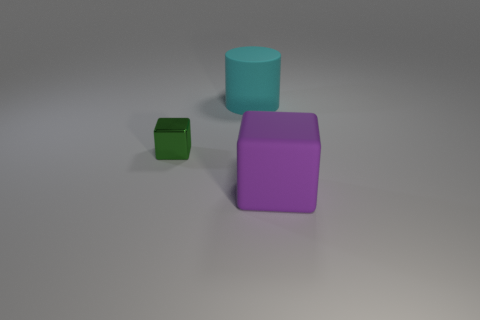Is there a green metallic cube? Upon reviewing the image, it appears that there is no green metallic cube present. Instead, there is a small green cube with a matte surface, alongside a purple cube and a teal cylinder. 